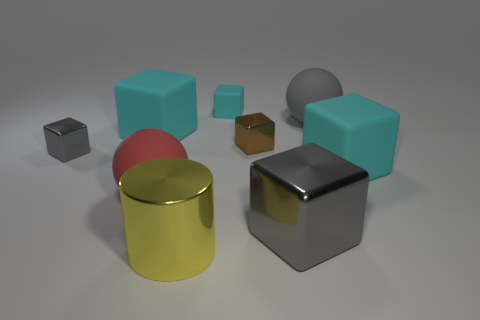The matte object that is the same color as the big shiny block is what shape?
Give a very brief answer. Sphere. Is the color of the large matte object to the left of the red object the same as the rubber cube that is in front of the small brown cube?
Your answer should be very brief. Yes. What size is the rubber ball that is the same color as the big shiny block?
Your answer should be compact. Large. There is a large sphere that is on the right side of the tiny brown cube; is it the same color as the large metallic block?
Provide a succinct answer. Yes. Is the material of the small brown cube the same as the large red thing?
Your answer should be very brief. No. The gray metal thing on the left side of the tiny thing behind the big gray thing that is behind the big gray cube is what shape?
Your answer should be compact. Cube. What is the object that is behind the brown metal block and left of the large yellow metallic object made of?
Provide a short and direct response. Rubber. What is the color of the big cube that is in front of the ball in front of the cyan matte object on the right side of the tiny brown thing?
Make the answer very short. Gray. What number of gray things are either metal blocks or big cubes?
Provide a short and direct response. 2. What number of other things are there of the same size as the gray matte thing?
Provide a short and direct response. 5. 